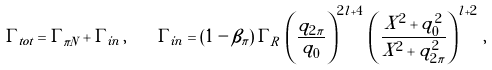Convert formula to latex. <formula><loc_0><loc_0><loc_500><loc_500>\Gamma _ { t o t } = \Gamma _ { \pi N } + \Gamma _ { i n } \, , \quad \Gamma _ { i n } = ( 1 - \beta _ { \pi } ) \, \Gamma _ { R } \, \left ( \frac { q _ { 2 \pi } } { q _ { 0 } } \right ) ^ { 2 l + 4 } \, \left ( \frac { X ^ { 2 } + q _ { 0 } ^ { 2 } } { X ^ { 2 } + q _ { 2 \pi } ^ { 2 } } \right ) ^ { l + 2 } \, ,</formula> 